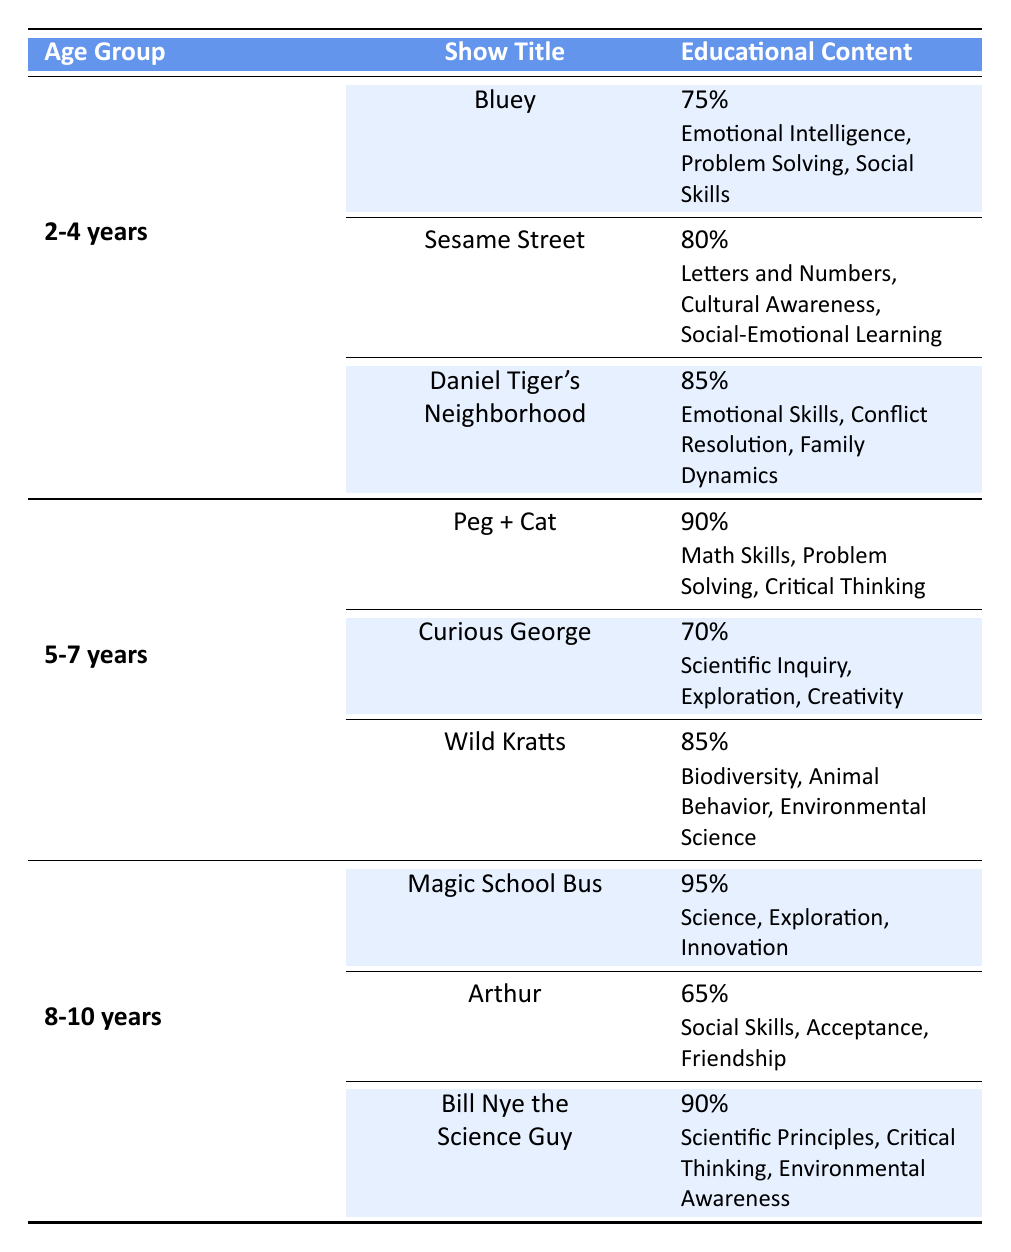What is the title of the show with the highest frequency of educational content for the age group 2-4 years? In the age group of 2-4 years, the shows listed are Bluey, Sesame Street, and Daniel Tiger's Neighborhood. Among these, Daniel Tiger's Neighborhood has the highest frequency of educational content at 85%.
Answer: Daniel Tiger's Neighborhood Which educational topic is covered by Sesame Street? The show Sesame Street covers the educational topics of Letters and Numbers, Cultural Awareness, and Social-Emotional Learning.
Answer: Letters and Numbers, Cultural Awareness, and Social-Emotional Learning Is the frequency of educational content for Curious George higher than for Wild Kratts? Curious George has a frequency of educational content of 70%, while Wild Kratts has a frequency of 85%. Since 70% is less than 85%, the statement is false.
Answer: No What is the average frequency of educational content for shows in the 5-7 years age group? The shows in the 5-7 years age group and their frequencies are Peg + Cat (90%), Curious George (70%), and Wild Kratts (85%). To find the average, sum the frequencies: 90 + 70 + 85 = 245. Divide by the number of shows (3): 245 / 3 = 81.67%.
Answer: 81.67% Which age group has the show with the highest frequency of educational content, and what is that frequency? The shows from the age groups are as follows: Magic School Bus (95%) for 8-10 years, Daniel Tiger's Neighborhood (85%) for 2-4 years, and Peg + Cat (90%) for 5-7 years. The highest frequency is 95% from the Magic School Bus in the 8-10 years age group.
Answer: 8-10 years, 95% 